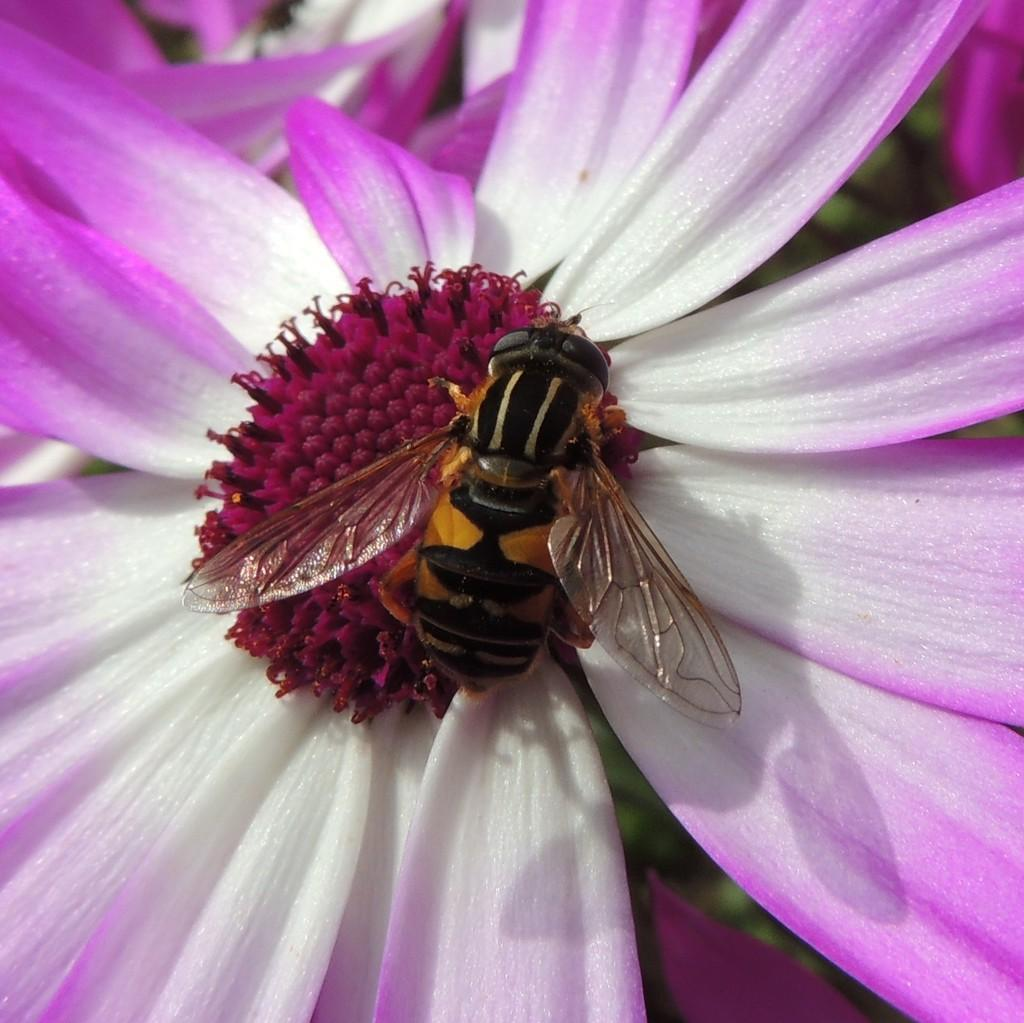What is the main subject of the image? The main subject of the image is an ant. Where is the ant located in the image? The ant is on a flower. What color is the background of the image? The background of the image is green. How much water can be seen in the image? There is no water visible in the image; it features an ant on a flower with a green background. 